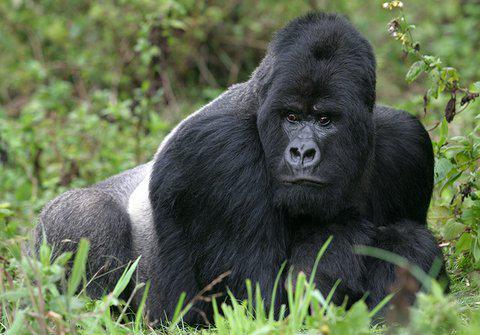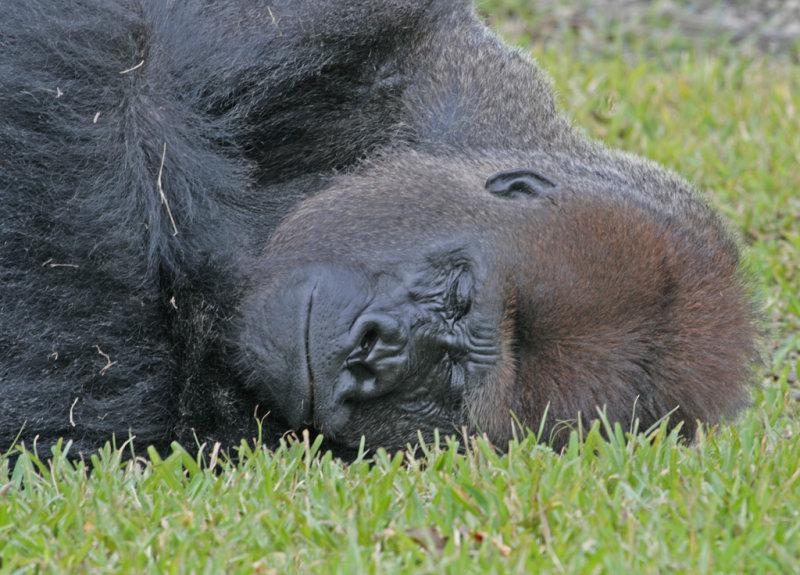The first image is the image on the left, the second image is the image on the right. Assess this claim about the two images: "The right image contains a gorilla lying on the grass with its head facing forward and the top of its head on the right.". Correct or not? Answer yes or no. Yes. The first image is the image on the left, the second image is the image on the right. For the images displayed, is the sentence "There are two gorillas laying down" factually correct? Answer yes or no. No. 